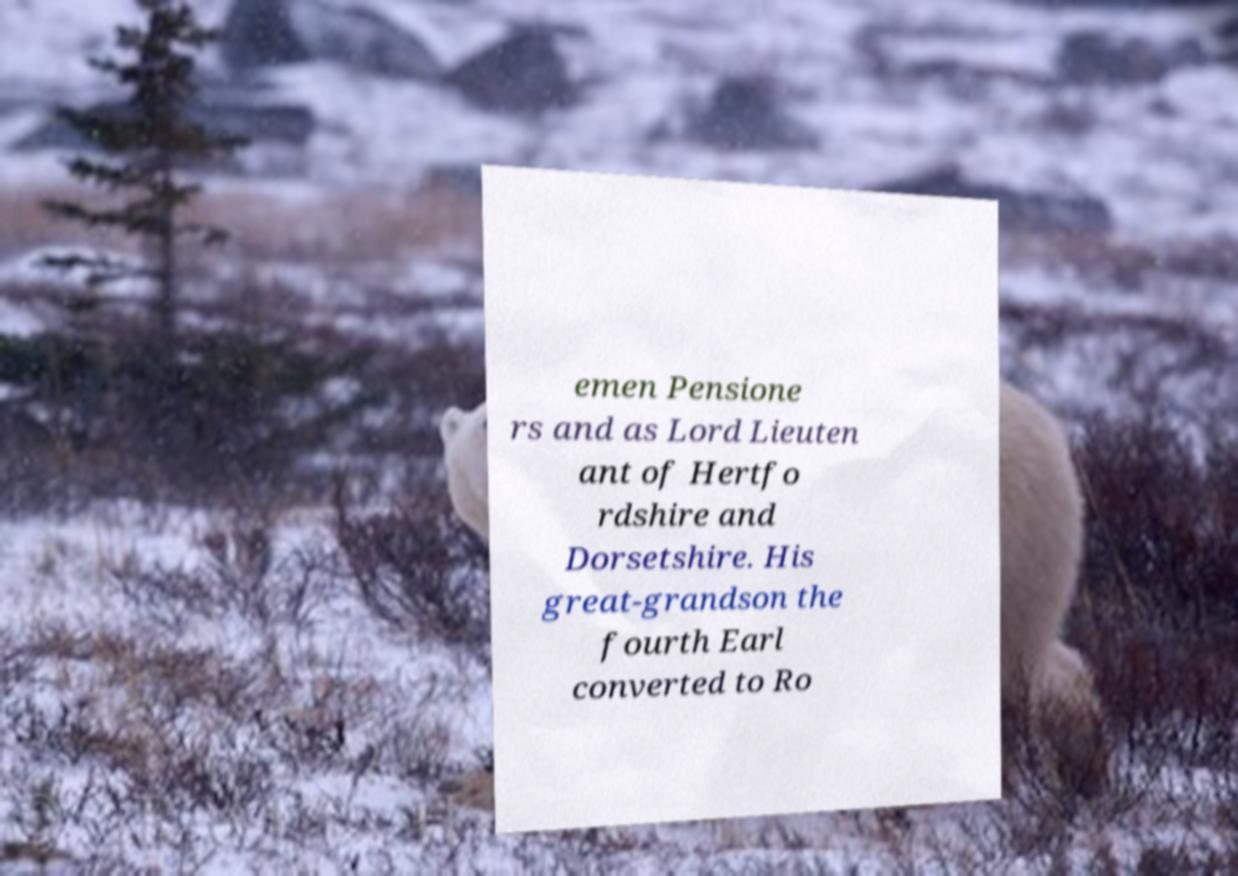Please read and relay the text visible in this image. What does it say? emen Pensione rs and as Lord Lieuten ant of Hertfo rdshire and Dorsetshire. His great-grandson the fourth Earl converted to Ro 